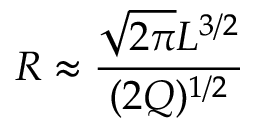<formula> <loc_0><loc_0><loc_500><loc_500>R \approx \frac { \sqrt { 2 \pi } L ^ { 3 / 2 } } { ( 2 Q ) ^ { 1 / 2 } }</formula> 